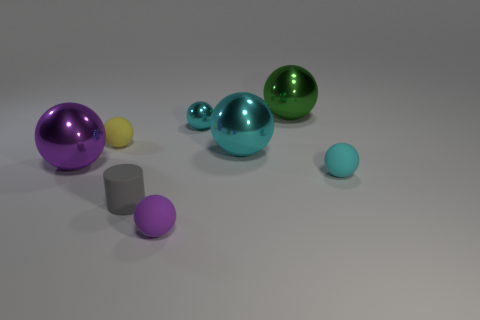The matte sphere behind the shiny ball left of the cyan metal sphere that is behind the tiny yellow rubber ball is what color?
Make the answer very short. Yellow. Are there any small gray rubber cylinders?
Offer a very short reply. Yes. What number of other objects are there of the same size as the cyan rubber sphere?
Offer a terse response. 4. Is the color of the small rubber cylinder the same as the rubber ball that is on the right side of the big green ball?
Your answer should be very brief. No. What number of things are either cyan spheres or small brown cylinders?
Provide a succinct answer. 3. Is there any other thing that has the same color as the rubber cylinder?
Give a very brief answer. No. Is the material of the large cyan ball the same as the small thing in front of the matte cylinder?
Your response must be concise. No. What is the shape of the small yellow object that is to the right of the ball on the left side of the yellow rubber ball?
Ensure brevity in your answer.  Sphere. The tiny object that is on the right side of the tiny gray matte thing and behind the purple metal ball has what shape?
Your answer should be compact. Sphere. How many things are either big green shiny balls or balls that are behind the large purple shiny sphere?
Make the answer very short. 4. 